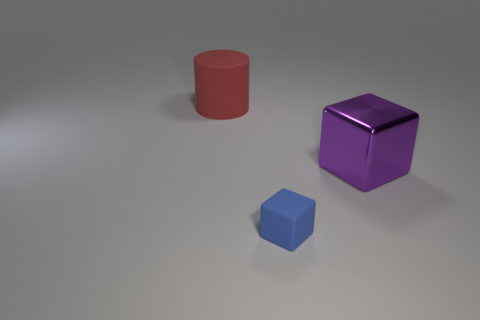How might light and shadow play a role in the perception of these objects? Light and shadow are vital in defining the three-dimensional form of the objects and provide cues about their texture and material. They also contribute to the perception of space and depth within the scene, with shadows anchoring the objects to the surface and the lighting suggesting a specific direction and intensity. 